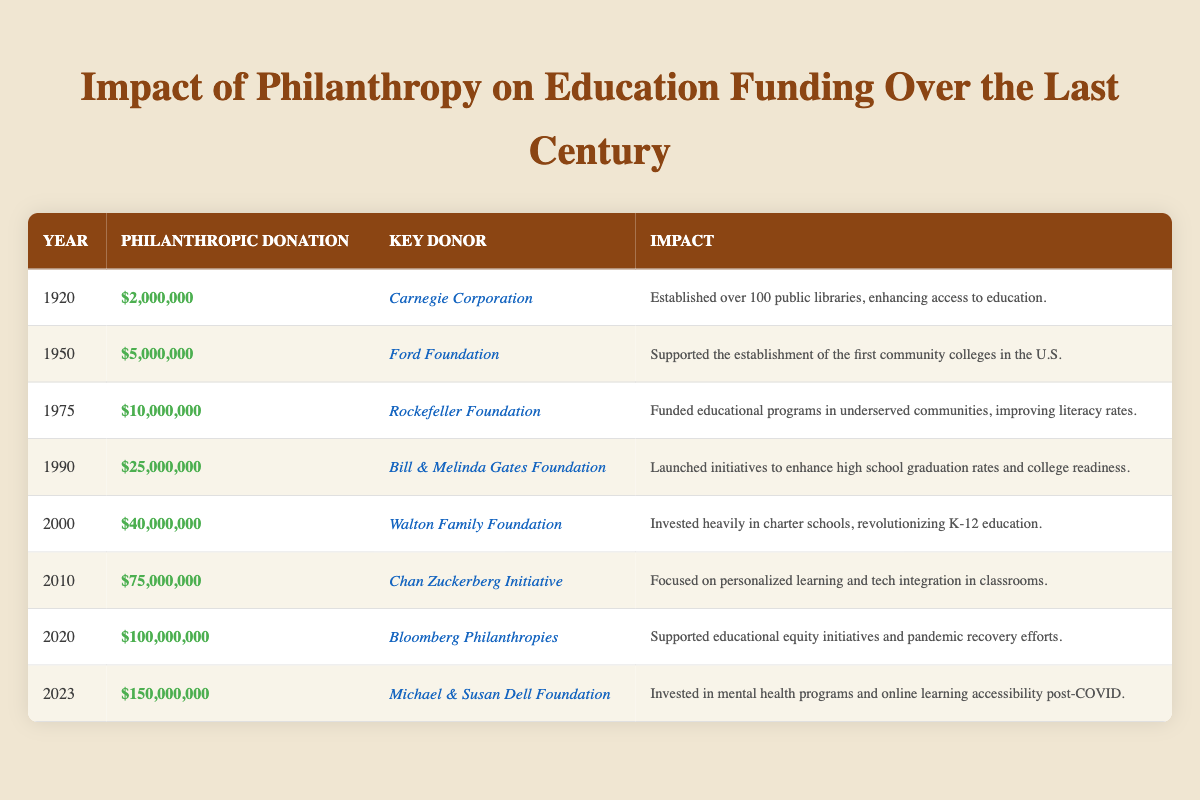What was the philanthropic donation made by the Bill & Melinda Gates Foundation in 1990? In the table, locate the row for the year 1990, where the philanthropic donation amount is clearly stated as $25,000,000.
Answer: $25,000,000 Who was the key donor for the largest philanthropic donation to education funding listed in the table? The largest philanthropic donation in the table is $150,000,000 made in 2023 by the Michael & Susan Dell Foundation.
Answer: Michael & Susan Dell Foundation What was the total philanthropic donation from 2000 to 2023? Add the donations for the years 2000 ($40,000,000), 2010 ($75,000,000), 2020 ($100,000,000), and 2023 ($150,000,000). The sum is $40,000,000 + $75,000,000 + $100,000,000 + $150,000,000 = $365,000,000.
Answer: $365,000,000 Which key donor has been responsible for a donation that notably improved literacy rates in underserved communities? In the table, the Rockefeller Foundation is identified as the key donor for the year 1975, which had a significant impact on improving literacy rates.
Answer: Rockefeller Foundation How many years passed between the first philanthropic donation in 1920 and the largest donation in 2023? The difference between 2023 and 1920 is 2023 - 1920 = 103 years.
Answer: 103 years Was there any philanthropic donation made after 2020? In the table, there is a record of a donation in 2023, which confirms that there was a donation made after 2020.
Answer: Yes Which donation had the most significant impact on establishing community colleges in the U.S.? The Ford Foundation made a donation of $5,000,000 in 1950 specifically to support the establishment of community colleges in the U.S.
Answer: Ford Foundation What is the average philanthropic donation amount from 1920 to 2023? To find the average, sum all donations: $2,000,000 + $5,000,000 + $10,000,000 + $25,000,000 + $40,000,000 + $75,000,000 + $100,000,000 + $150,000,000 = $407,000,000. There are 8 donations, so the average is $407,000,000 ÷ 8 = $50,875,000.
Answer: $50,875,000 Which philanthropic initiative focused on mental health and online learning post-COVID? The Michael & Susan Dell Foundation is noted for investing in mental health programs and online learning accessibility post-COVID in 2023.
Answer: Michael & Susan Dell Foundation What was the impact of the donation made by Bloomberg Philanthropies in 2020? The $100,000,000 donation by Bloomberg Philanthropies supported educational equity initiatives and pandemic recovery efforts.
Answer: Supported educational equity initiatives and pandemic recovery efforts 